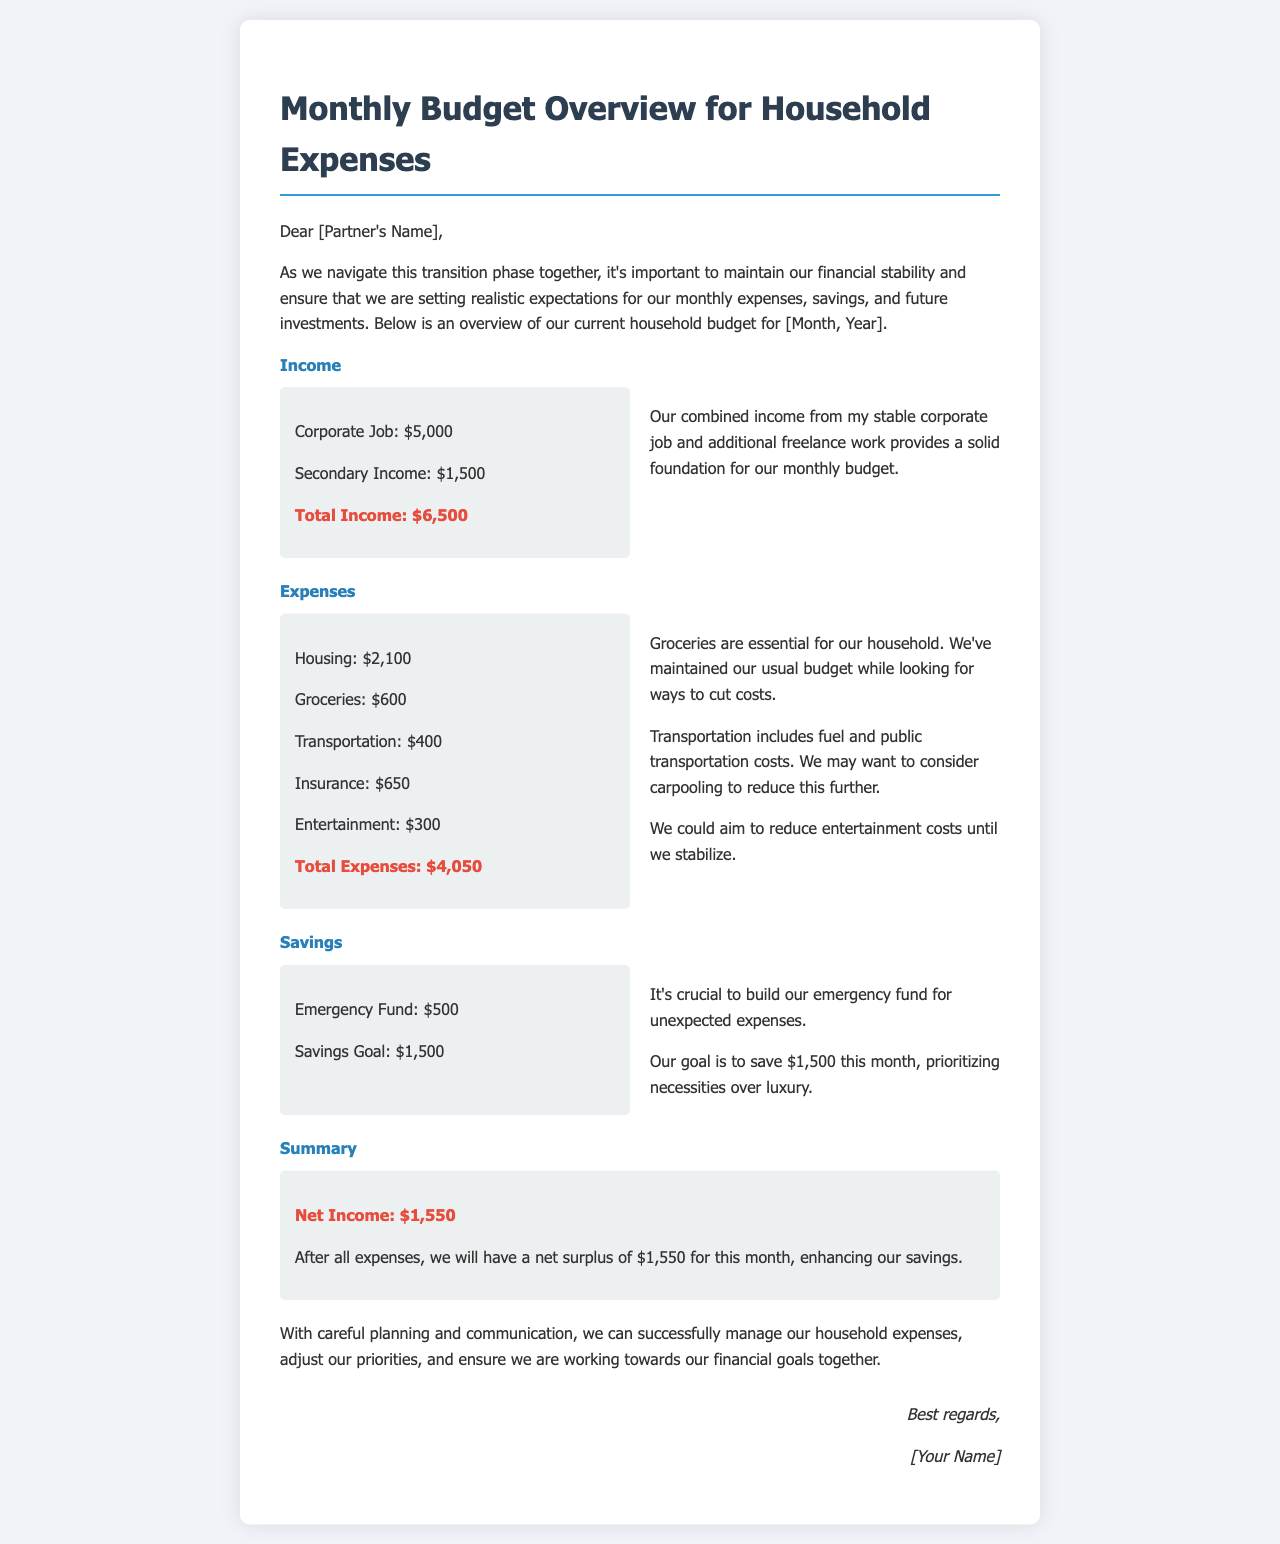what is the total income? The total income is the sum of the corporate job and secondary income, which is $5,000 + $1,500.
Answer: $6,500 what is the monthly budget for groceries? The document specifies the monthly budget for groceries, which is listed under expenses.
Answer: $600 how much is allocated for the emergency fund? The letter outlines the amount set aside for the emergency fund, which is mentioned in the savings section.
Answer: $500 what is the total amount spent on housing? The total amount spent on housing is stated in the expenses section of the document.
Answer: $2,100 what is the net income after expenses? The net income is calculated as total income minus total expenses, which is detailed in the summary section.
Answer: $1,550 how much do we aim to save this month? The savings goal is specifically mentioned in the savings section of the document.
Answer: $1,500 what aspect of our expenses suggests a potential area for cost-cutting? The section discusses different expenses, particularly highlighting areas where we might cut back.
Answer: Entertainment who is the intended recipient of this letter? The greeting at the beginning of the letter specifies the person to whom the letter is addressed.
Answer: [Partner's Name] what month does this budget overview cover? The opening paragraph indicates the month for which this budget overview is prepared.
Answer: [Month, Year] 